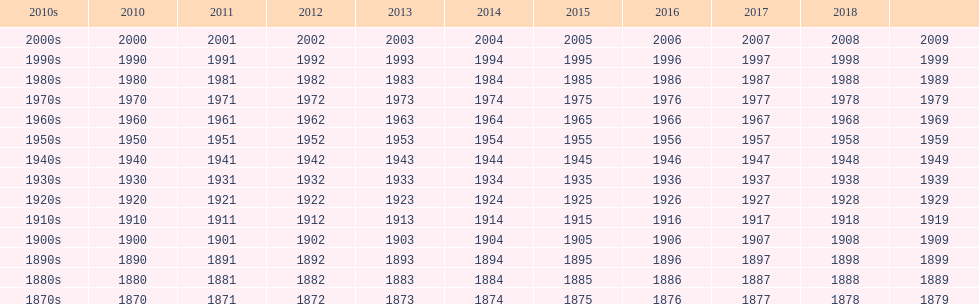In which decade are there fewer years present compared to the other decades? 2010s. 